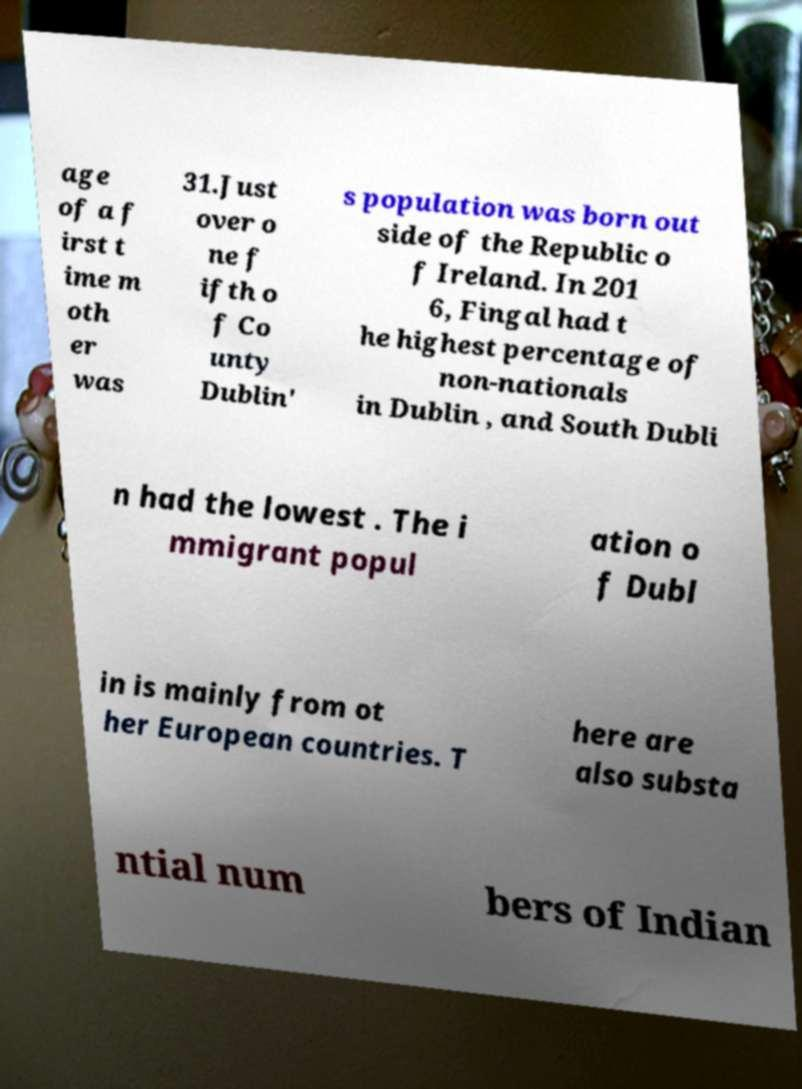Please identify and transcribe the text found in this image. age of a f irst t ime m oth er was 31.Just over o ne f ifth o f Co unty Dublin' s population was born out side of the Republic o f Ireland. In 201 6, Fingal had t he highest percentage of non-nationals in Dublin , and South Dubli n had the lowest . The i mmigrant popul ation o f Dubl in is mainly from ot her European countries. T here are also substa ntial num bers of Indian 